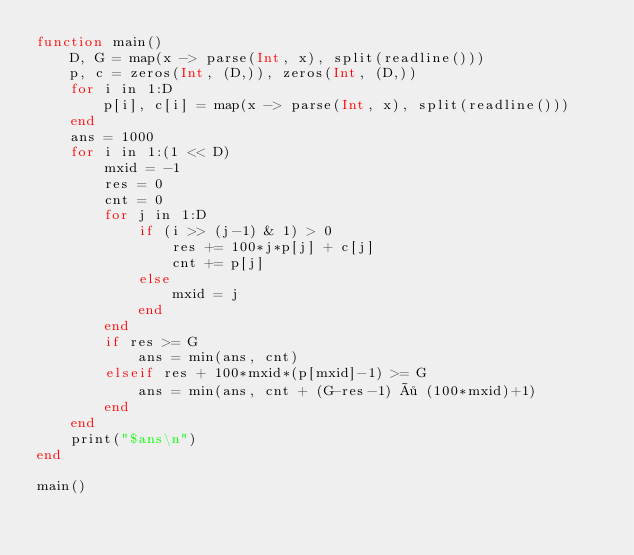Convert code to text. <code><loc_0><loc_0><loc_500><loc_500><_Julia_>function main()
    D, G = map(x -> parse(Int, x), split(readline()))
    p, c = zeros(Int, (D,)), zeros(Int, (D,))
    for i in 1:D
        p[i], c[i] = map(x -> parse(Int, x), split(readline()))
    end
    ans = 1000
    for i in 1:(1 << D)
        mxid = -1
        res = 0
        cnt = 0
        for j in 1:D
            if (i >> (j-1) & 1) > 0
                res += 100*j*p[j] + c[j]
                cnt += p[j]
            else
                mxid = j
            end
        end
        if res >= G
            ans = min(ans, cnt)
        elseif res + 100*mxid*(p[mxid]-1) >= G
            ans = min(ans, cnt + (G-res-1) ÷ (100*mxid)+1)
        end
    end
    print("$ans\n")
end

main()
</code> 